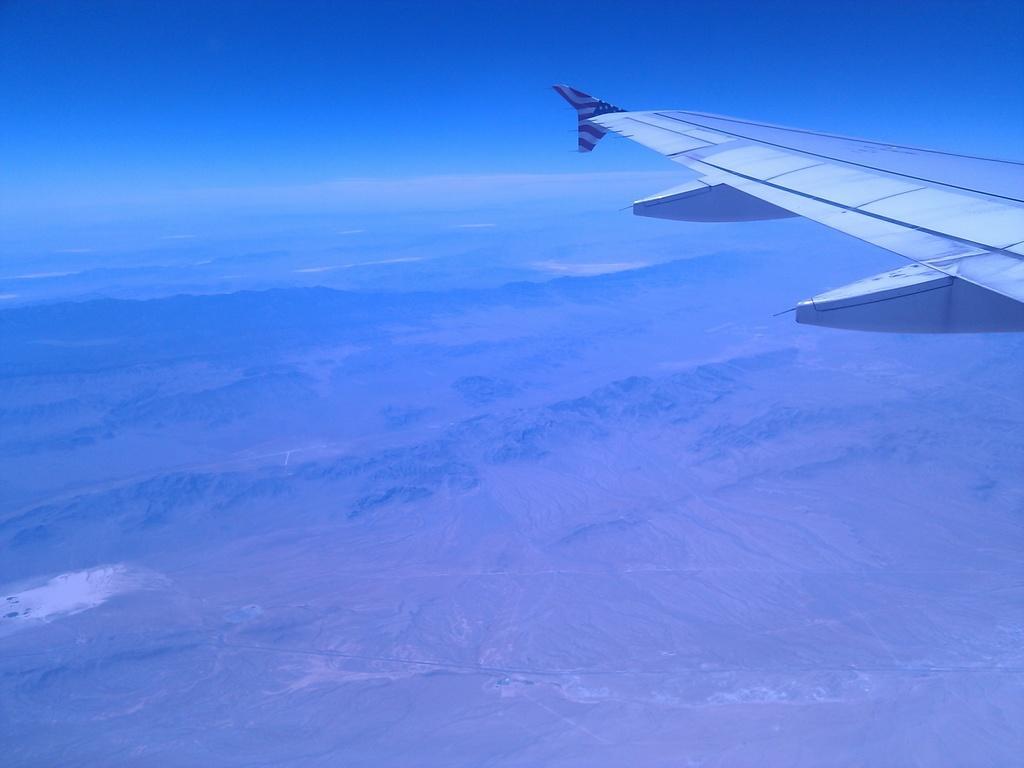Could you give a brief overview of what you see in this image? This image is taken outdoors. At the top of the image there is the sky. On the right side of the image an airplane is flying in the sky. At the bottom of the image there is a ground. 